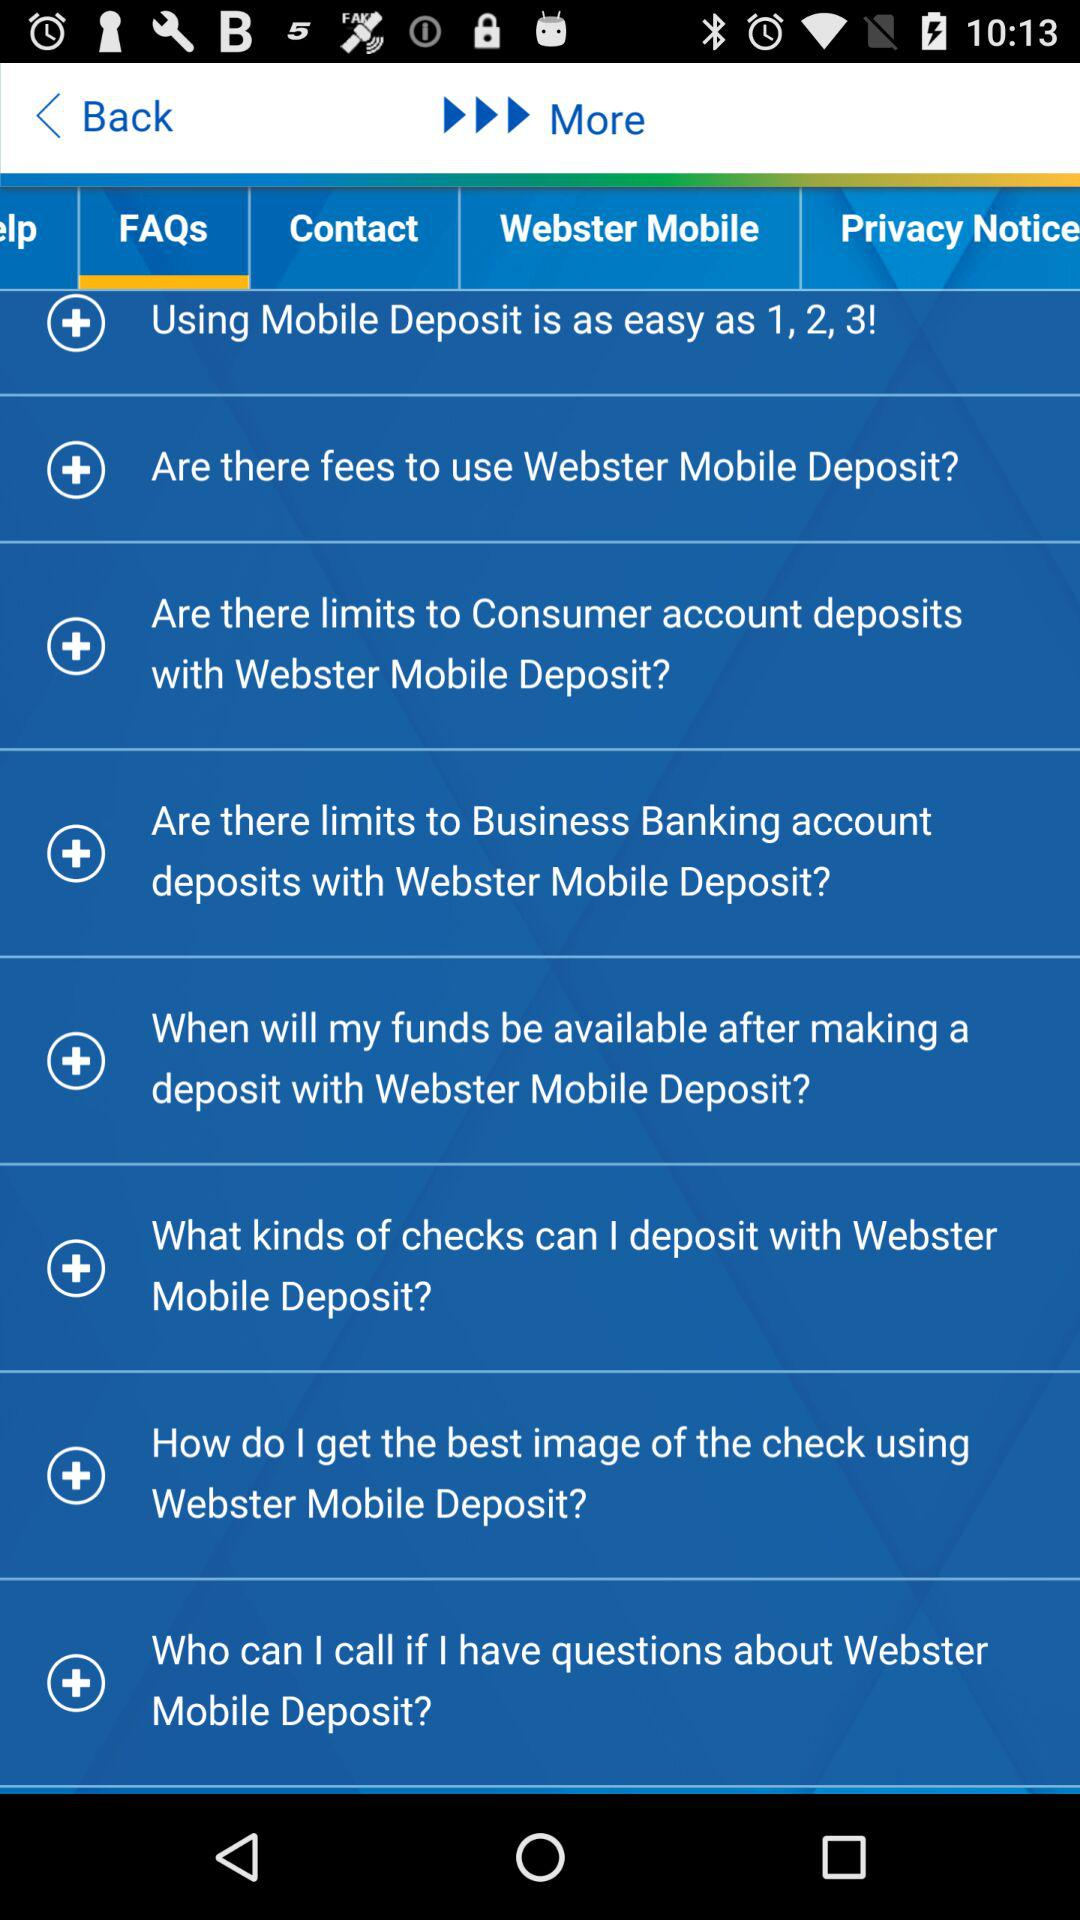How many FAQs are there about Webster Mobile Deposit?
Answer the question using a single word or phrase. 8 